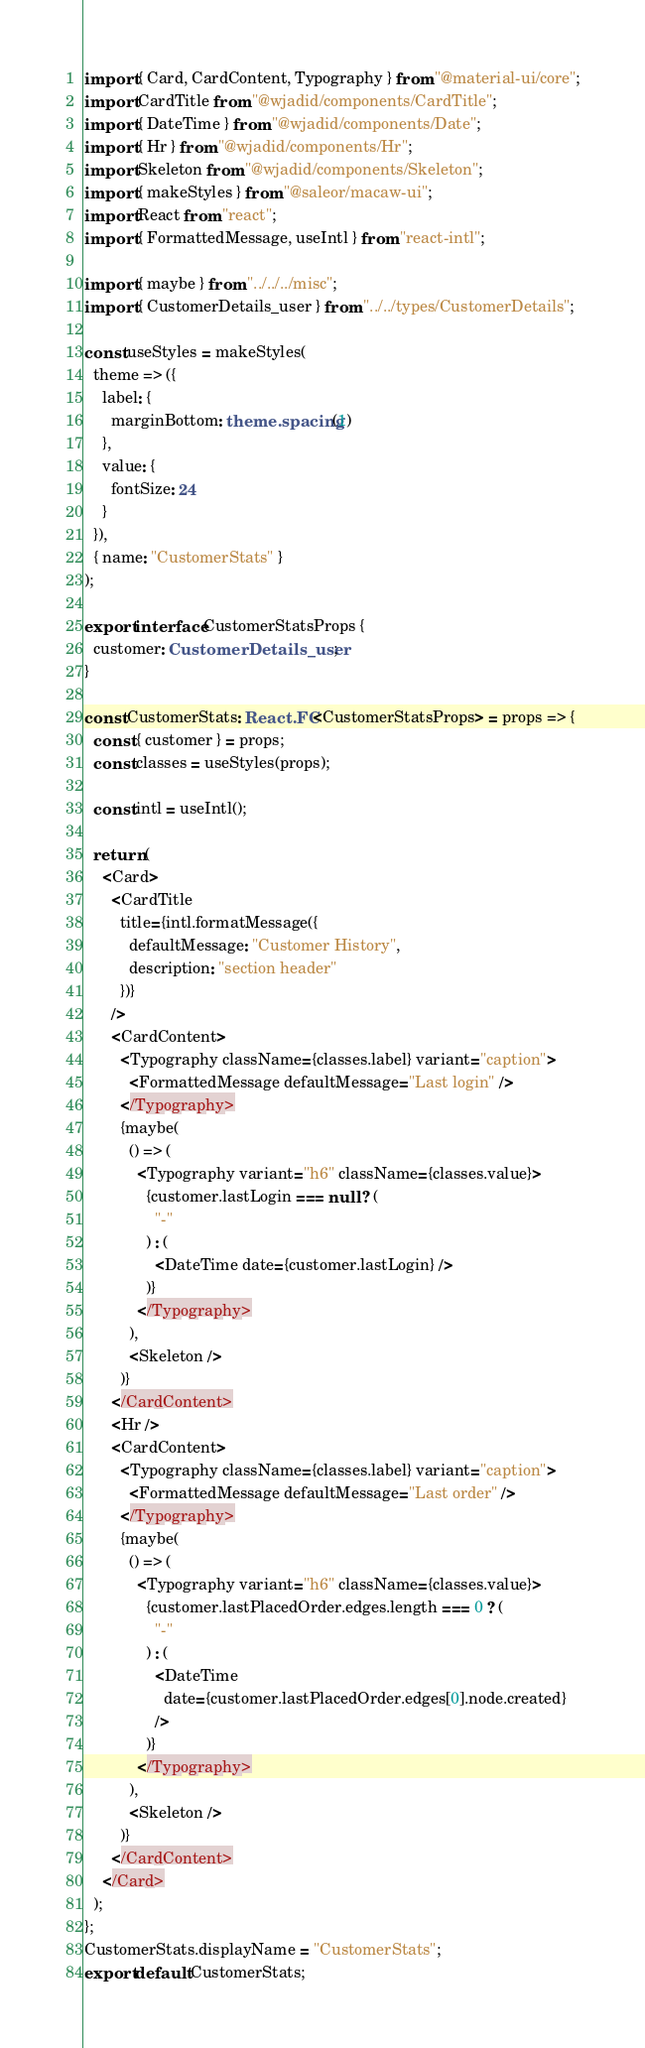Convert code to text. <code><loc_0><loc_0><loc_500><loc_500><_TypeScript_>import { Card, CardContent, Typography } from "@material-ui/core";
import CardTitle from "@wjadid/components/CardTitle";
import { DateTime } from "@wjadid/components/Date";
import { Hr } from "@wjadid/components/Hr";
import Skeleton from "@wjadid/components/Skeleton";
import { makeStyles } from "@saleor/macaw-ui";
import React from "react";
import { FormattedMessage, useIntl } from "react-intl";

import { maybe } from "../../../misc";
import { CustomerDetails_user } from "../../types/CustomerDetails";

const useStyles = makeStyles(
  theme => ({
    label: {
      marginBottom: theme.spacing(1)
    },
    value: {
      fontSize: 24
    }
  }),
  { name: "CustomerStats" }
);

export interface CustomerStatsProps {
  customer: CustomerDetails_user;
}

const CustomerStats: React.FC<CustomerStatsProps> = props => {
  const { customer } = props;
  const classes = useStyles(props);

  const intl = useIntl();

  return (
    <Card>
      <CardTitle
        title={intl.formatMessage({
          defaultMessage: "Customer History",
          description: "section header"
        })}
      />
      <CardContent>
        <Typography className={classes.label} variant="caption">
          <FormattedMessage defaultMessage="Last login" />
        </Typography>
        {maybe(
          () => (
            <Typography variant="h6" className={classes.value}>
              {customer.lastLogin === null ? (
                "-"
              ) : (
                <DateTime date={customer.lastLogin} />
              )}
            </Typography>
          ),
          <Skeleton />
        )}
      </CardContent>
      <Hr />
      <CardContent>
        <Typography className={classes.label} variant="caption">
          <FormattedMessage defaultMessage="Last order" />
        </Typography>
        {maybe(
          () => (
            <Typography variant="h6" className={classes.value}>
              {customer.lastPlacedOrder.edges.length === 0 ? (
                "-"
              ) : (
                <DateTime
                  date={customer.lastPlacedOrder.edges[0].node.created}
                />
              )}
            </Typography>
          ),
          <Skeleton />
        )}
      </CardContent>
    </Card>
  );
};
CustomerStats.displayName = "CustomerStats";
export default CustomerStats;
</code> 